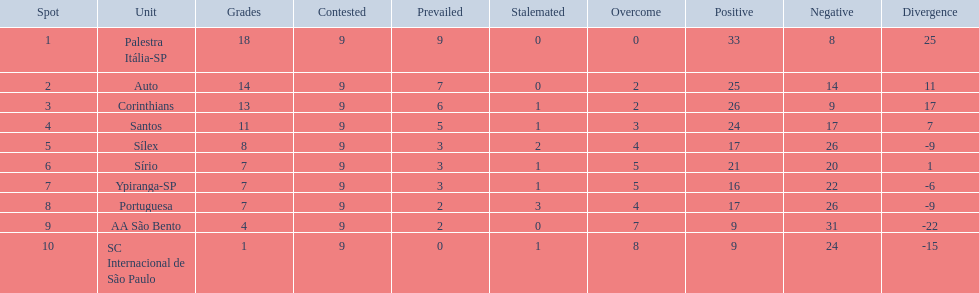How many teams played football in brazil during the year 1926? Palestra Itália-SP, Auto, Corinthians, Santos, Sílex, Sírio, Ypiranga-SP, Portuguesa, AA São Bento, SC Internacional de São Paulo. Give me the full table as a dictionary. {'header': ['Spot', 'Unit', 'Grades', 'Contested', 'Prevailed', 'Stalemated', 'Overcome', 'Positive', 'Negative', 'Divergence'], 'rows': [['1', 'Palestra Itália-SP', '18', '9', '9', '0', '0', '33', '8', '25'], ['2', 'Auto', '14', '9', '7', '0', '2', '25', '14', '11'], ['3', 'Corinthians', '13', '9', '6', '1', '2', '26', '9', '17'], ['4', 'Santos', '11', '9', '5', '1', '3', '24', '17', '7'], ['5', 'Sílex', '8', '9', '3', '2', '4', '17', '26', '-9'], ['6', 'Sírio', '7', '9', '3', '1', '5', '21', '20', '1'], ['7', 'Ypiranga-SP', '7', '9', '3', '1', '5', '16', '22', '-6'], ['8', 'Portuguesa', '7', '9', '2', '3', '4', '17', '26', '-9'], ['9', 'AA São Bento', '4', '9', '2', '0', '7', '9', '31', '-22'], ['10', 'SC Internacional de São Paulo', '1', '9', '0', '1', '8', '9', '24', '-15']]} What was the highest number of games won during the 1926 season? 9. Which team was in the top spot with 9 wins for the 1926 season? Palestra Itália-SP. 